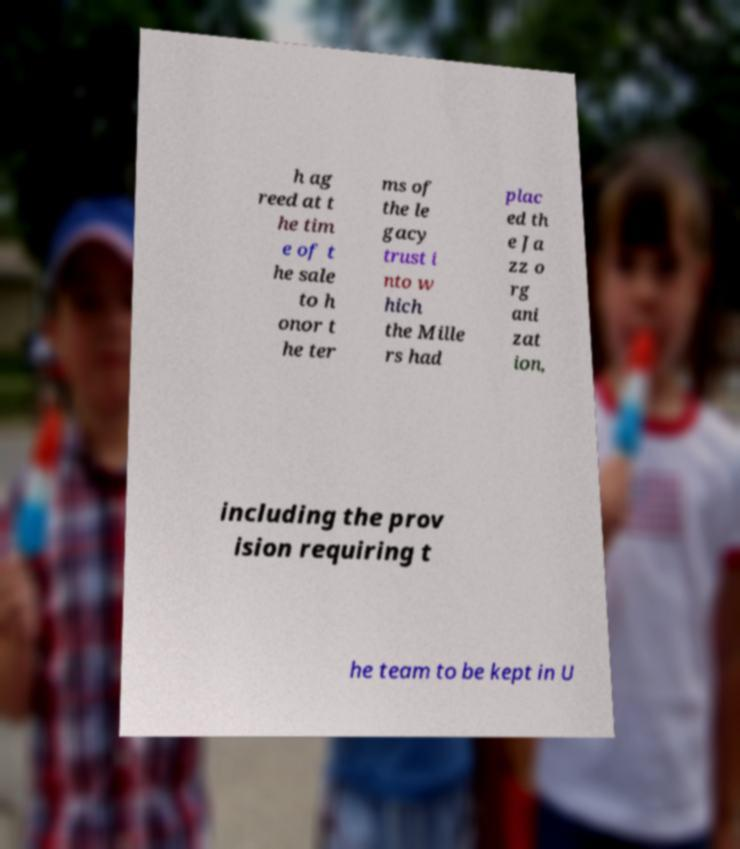Could you assist in decoding the text presented in this image and type it out clearly? h ag reed at t he tim e of t he sale to h onor t he ter ms of the le gacy trust i nto w hich the Mille rs had plac ed th e Ja zz o rg ani zat ion, including the prov ision requiring t he team to be kept in U 